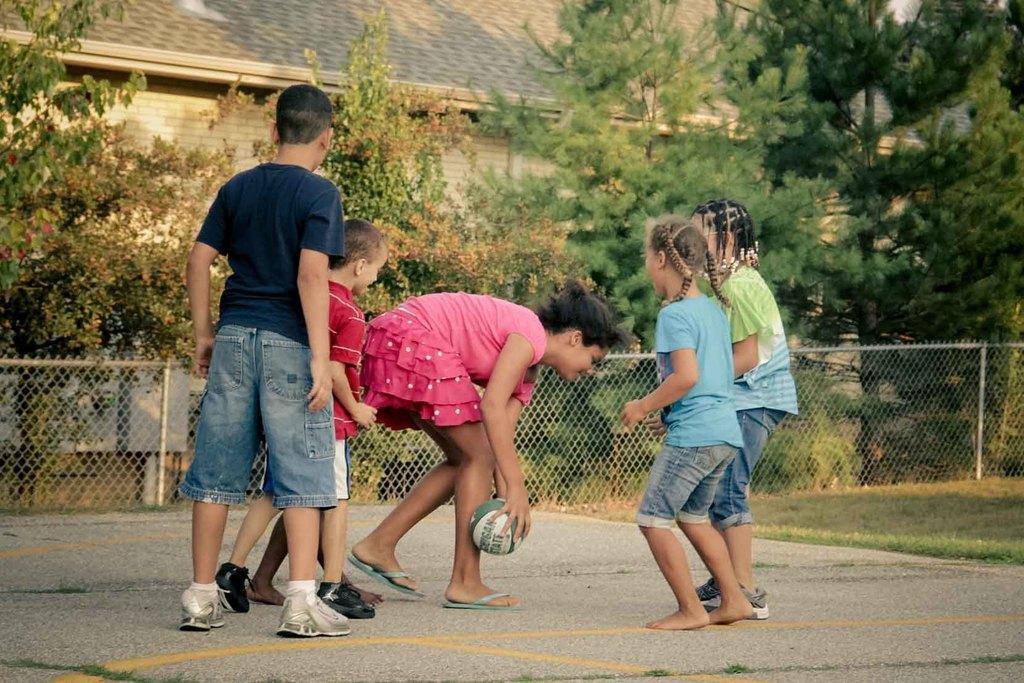Could you give a brief overview of what you see in this image? In the middle a girl is bending and holding the football with her hands. She wore pink color dress, on the left side two boys are standing. On the right side 2 girls are standing, at the back side there are trees and a house in this image. 